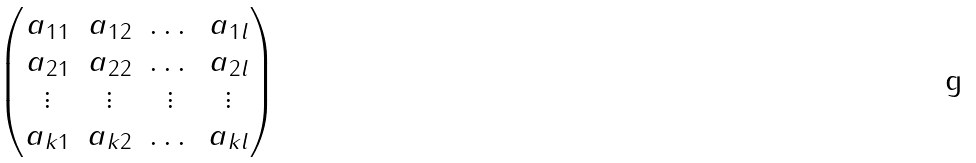Convert formula to latex. <formula><loc_0><loc_0><loc_500><loc_500>\begin{pmatrix} a _ { 1 1 } & a _ { 1 2 } & \dots & a _ { 1 l } \\ a _ { 2 1 } & a _ { 2 2 } & \dots & a _ { 2 l } \\ \vdots & \vdots & \vdots & \vdots \\ a _ { k 1 } & a _ { k 2 } & \dots & a _ { k l } \\ \end{pmatrix}</formula> 